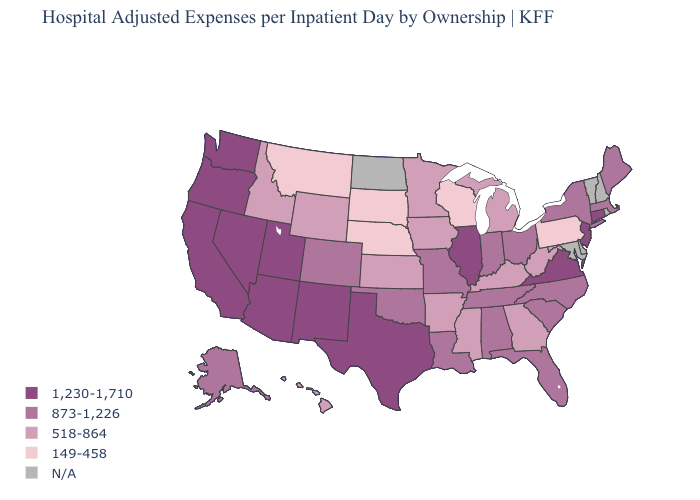Among the states that border West Virginia , does Kentucky have the lowest value?
Short answer required. No. Name the states that have a value in the range 873-1,226?
Short answer required. Alabama, Alaska, Colorado, Florida, Indiana, Louisiana, Maine, Massachusetts, Missouri, New York, North Carolina, Ohio, Oklahoma, South Carolina, Tennessee. What is the lowest value in the USA?
Be succinct. 149-458. Which states have the lowest value in the USA?
Quick response, please. Montana, Nebraska, Pennsylvania, South Dakota, Wisconsin. Among the states that border Montana , which have the highest value?
Be succinct. Idaho, Wyoming. Which states have the highest value in the USA?
Answer briefly. Arizona, California, Connecticut, Illinois, Nevada, New Jersey, New Mexico, Oregon, Texas, Utah, Virginia, Washington. What is the lowest value in the USA?
Answer briefly. 149-458. What is the value of Washington?
Short answer required. 1,230-1,710. Name the states that have a value in the range N/A?
Write a very short answer. Delaware, Maryland, New Hampshire, North Dakota, Rhode Island, Vermont. Name the states that have a value in the range 518-864?
Short answer required. Arkansas, Georgia, Hawaii, Idaho, Iowa, Kansas, Kentucky, Michigan, Minnesota, Mississippi, West Virginia, Wyoming. Which states have the lowest value in the MidWest?
Concise answer only. Nebraska, South Dakota, Wisconsin. Among the states that border Utah , does Arizona have the lowest value?
Keep it brief. No. Is the legend a continuous bar?
Short answer required. No. Name the states that have a value in the range 149-458?
Answer briefly. Montana, Nebraska, Pennsylvania, South Dakota, Wisconsin. What is the value of Texas?
Give a very brief answer. 1,230-1,710. 